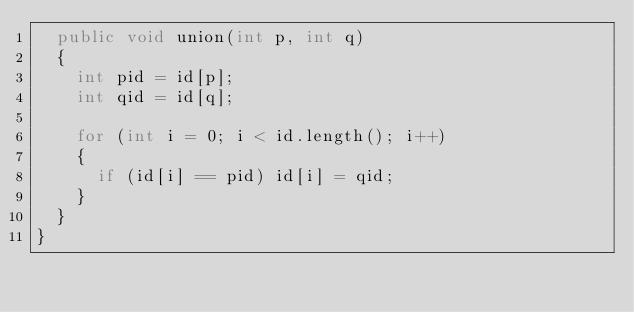<code> <loc_0><loc_0><loc_500><loc_500><_Java_>  public void union(int p, int q)
  {
    int pid = id[p];
    int qid = id[q];
    
    for (int i = 0; i < id.length(); i++)
    {
      if (id[i] == pid) id[i] = qid;
    }
  }
}
</code> 